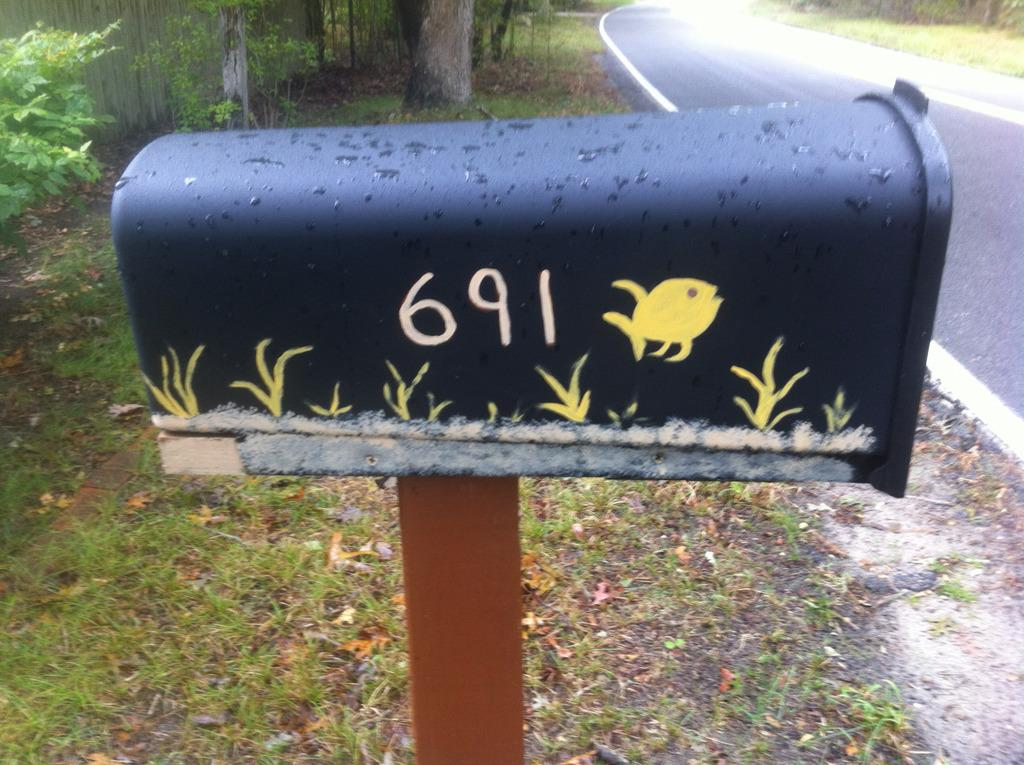What object is the main focus of the image? There is a letter box in the image. What can be seen in the background behind the letter box? There are trees behind the letter box. What type of vegetation covers the ground in the image? The ground is covered with grass. What year is depicted on the letter box in the image? There is no year visible on the letter box in the image. What type of humor can be found in the image? There is no humor present in the image; it is a straightforward depiction of a letter box, trees, and grass. 